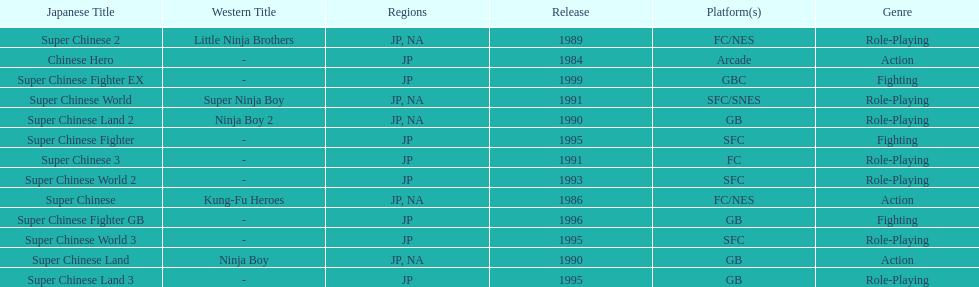Write the full table. {'header': ['Japanese Title', 'Western Title', 'Regions', 'Release', 'Platform(s)', 'Genre'], 'rows': [['Super Chinese 2', 'Little Ninja Brothers', 'JP, NA', '1989', 'FC/NES', 'Role-Playing'], ['Chinese Hero', '-', 'JP', '1984', 'Arcade', 'Action'], ['Super Chinese Fighter EX', '-', 'JP', '1999', 'GBC', 'Fighting'], ['Super Chinese World', 'Super Ninja Boy', 'JP, NA', '1991', 'SFC/SNES', 'Role-Playing'], ['Super Chinese Land 2', 'Ninja Boy 2', 'JP, NA', '1990', 'GB', 'Role-Playing'], ['Super Chinese Fighter', '-', 'JP', '1995', 'SFC', 'Fighting'], ['Super Chinese 3', '-', 'JP', '1991', 'FC', 'Role-Playing'], ['Super Chinese World 2', '-', 'JP', '1993', 'SFC', 'Role-Playing'], ['Super Chinese', 'Kung-Fu Heroes', 'JP, NA', '1986', 'FC/NES', 'Action'], ['Super Chinese Fighter GB', '-', 'JP', '1996', 'GB', 'Fighting'], ['Super Chinese World 3', '-', 'JP', '1995', 'SFC', 'Role-Playing'], ['Super Chinese Land', 'Ninja Boy', 'JP, NA', '1990', 'GB', 'Action'], ['Super Chinese Land 3', '-', 'JP', '1995', 'GB', 'Role-Playing']]} Number of super chinese world games released 3. 